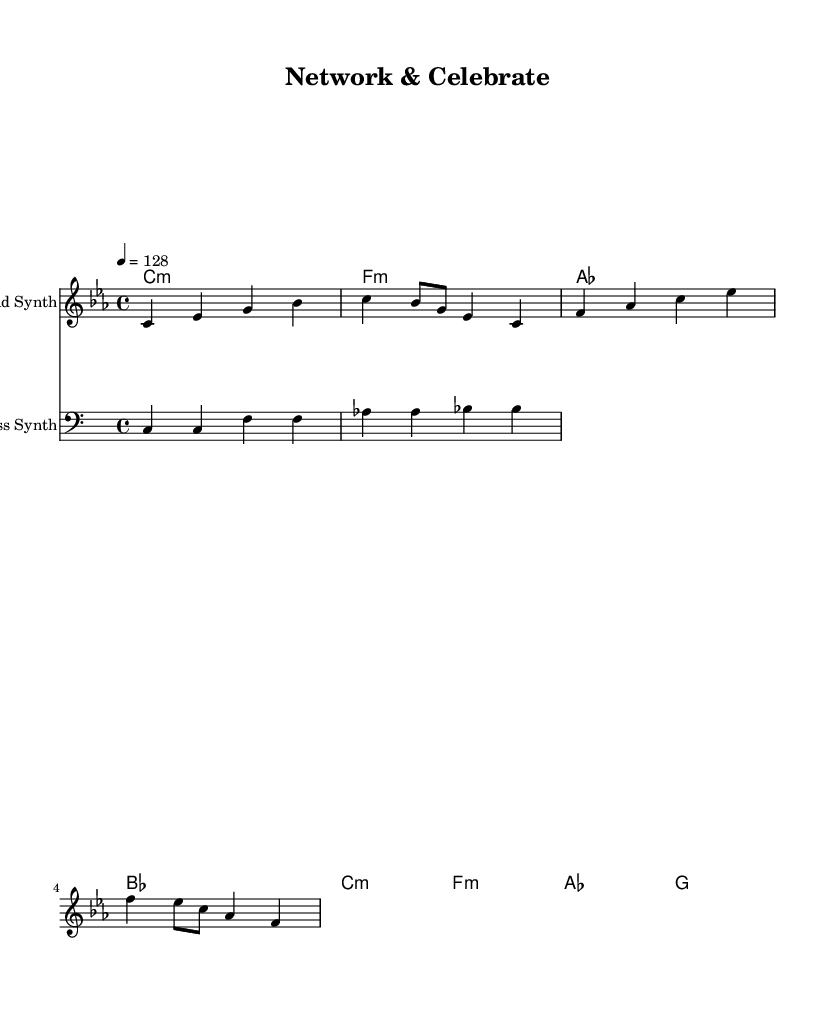What is the key signature of this music? The key signature is C minor, which has three flats (B♭, E♭, A♭). This is indicated at the beginning of the sheet music.
Answer: C minor What is the time signature of this music? The time signature is 4/4, which means there are four beats in each measure, and the quarter note receives one beat. This is typically indicated at the beginning of the score.
Answer: 4/4 What is the tempo marking of this music? The tempo marking is indicated as 128 beats per minute, meaning the basic speed of the music is fast-paced. This is usually shown above the staff.
Answer: 128 How many measures are there in the melody? The melody consists of four measures, as separated by vertical lines (bar lines) on the music sheet. Each measure contains a specific number of beats defined by the time signature.
Answer: 4 What type of chord is starting the harmony section? The first chord in the harmony section is a C minor chord, which is labeled as "c:m" in the chord notation. This indicates a minor quality for the chord.
Answer: C minor What is the role of the bass line in this piece? The bass line serves as a foundational support for the harmony, often playing root notes of the chords or providing rhythmic drive. In hip hop, the bass is crucial for establishing groove.
Answer: Foundational support Which section of the music integrates with synth sounds specifically designed for parties? The lead synth section integrates melodic hooks designed to engage listeners and elevate the energy, which is characteristic of upbeat hip hop party anthems.
Answer: Lead synth 